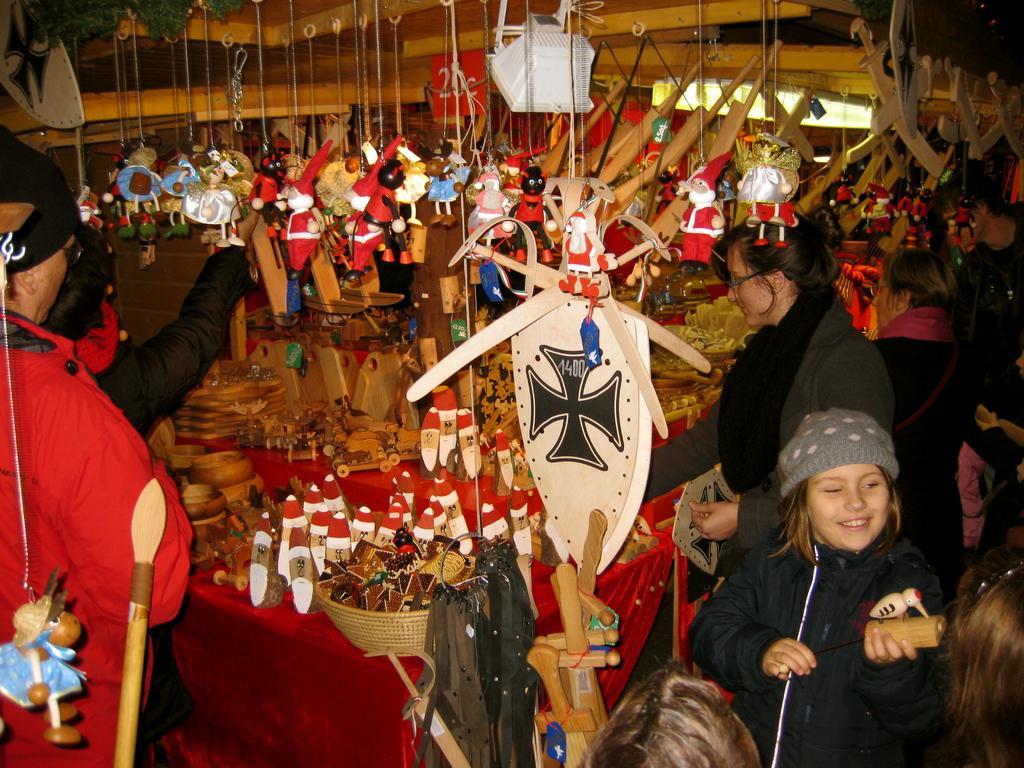Can you describe this image briefly? In this image I can see number of persons are standing, red colored table and number of wooden objects on the table. I can see a wooden basket with few objects in it. I can see number of toys are hanged to the top. 